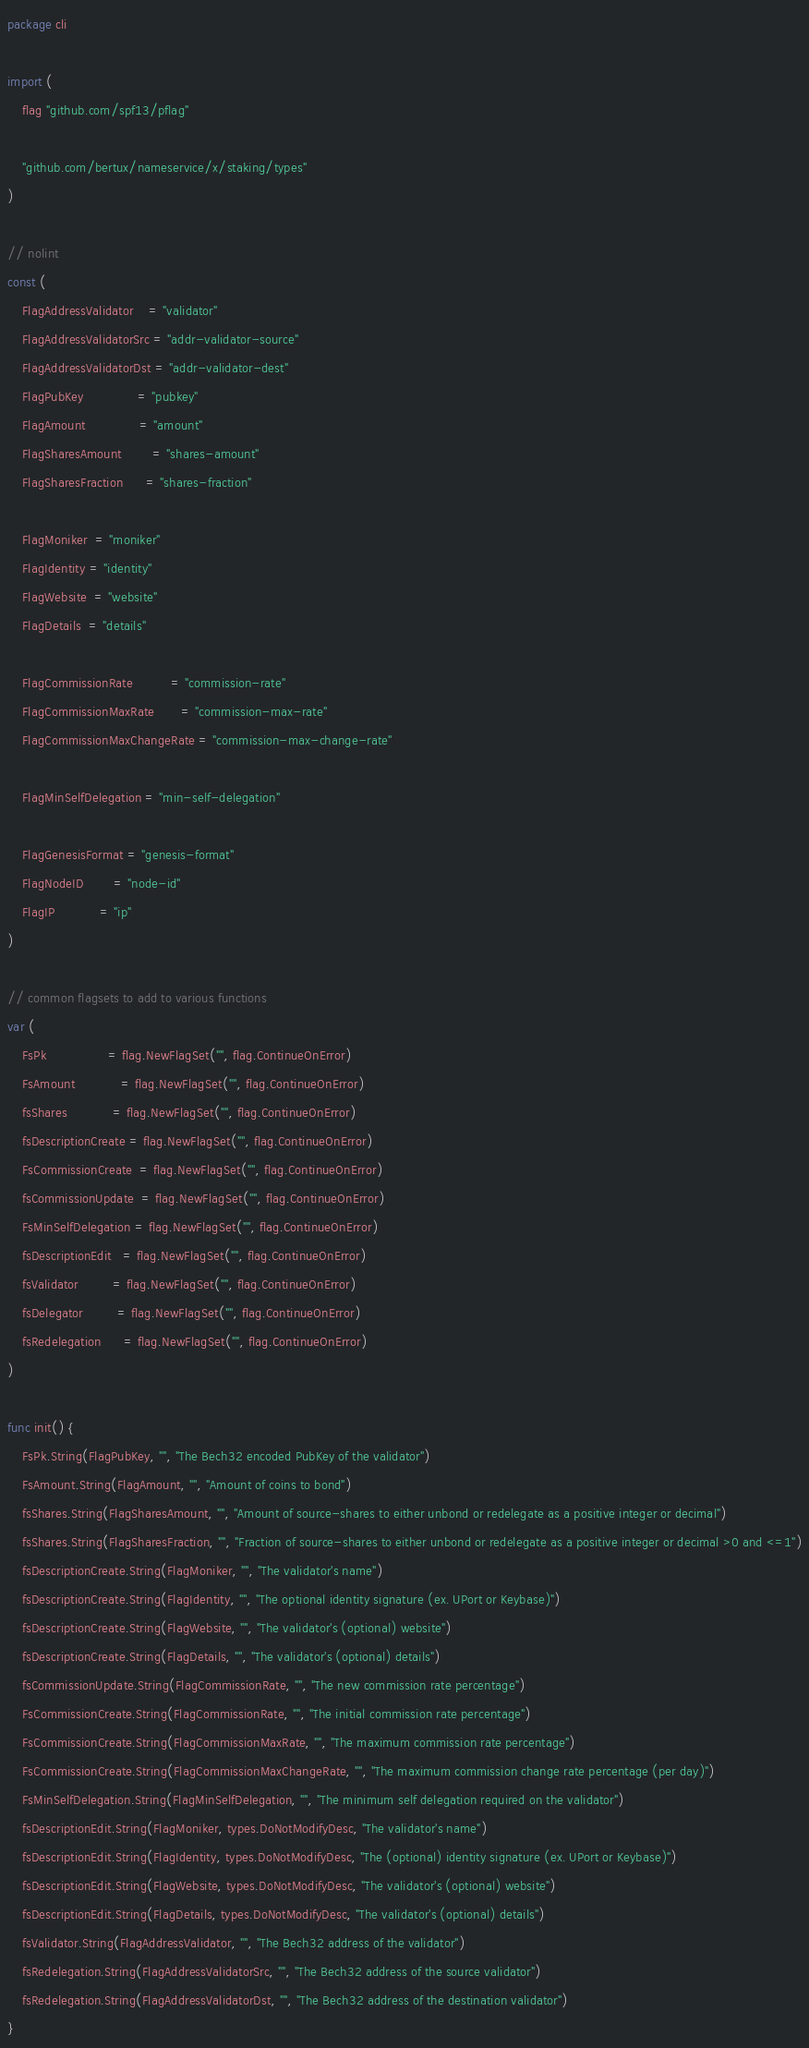Convert code to text. <code><loc_0><loc_0><loc_500><loc_500><_Go_>package cli

import (
	flag "github.com/spf13/pflag"

	"github.com/bertux/nameservice/x/staking/types"
)

// nolint
const (
	FlagAddressValidator    = "validator"
	FlagAddressValidatorSrc = "addr-validator-source"
	FlagAddressValidatorDst = "addr-validator-dest"
	FlagPubKey              = "pubkey"
	FlagAmount              = "amount"
	FlagSharesAmount        = "shares-amount"
	FlagSharesFraction      = "shares-fraction"

	FlagMoniker  = "moniker"
	FlagIdentity = "identity"
	FlagWebsite  = "website"
	FlagDetails  = "details"

	FlagCommissionRate          = "commission-rate"
	FlagCommissionMaxRate       = "commission-max-rate"
	FlagCommissionMaxChangeRate = "commission-max-change-rate"

	FlagMinSelfDelegation = "min-self-delegation"

	FlagGenesisFormat = "genesis-format"
	FlagNodeID        = "node-id"
	FlagIP            = "ip"
)

// common flagsets to add to various functions
var (
	FsPk                = flag.NewFlagSet("", flag.ContinueOnError)
	FsAmount            = flag.NewFlagSet("", flag.ContinueOnError)
	fsShares            = flag.NewFlagSet("", flag.ContinueOnError)
	fsDescriptionCreate = flag.NewFlagSet("", flag.ContinueOnError)
	FsCommissionCreate  = flag.NewFlagSet("", flag.ContinueOnError)
	fsCommissionUpdate  = flag.NewFlagSet("", flag.ContinueOnError)
	FsMinSelfDelegation = flag.NewFlagSet("", flag.ContinueOnError)
	fsDescriptionEdit   = flag.NewFlagSet("", flag.ContinueOnError)
	fsValidator         = flag.NewFlagSet("", flag.ContinueOnError)
	fsDelegator         = flag.NewFlagSet("", flag.ContinueOnError)
	fsRedelegation      = flag.NewFlagSet("", flag.ContinueOnError)
)

func init() {
	FsPk.String(FlagPubKey, "", "The Bech32 encoded PubKey of the validator")
	FsAmount.String(FlagAmount, "", "Amount of coins to bond")
	fsShares.String(FlagSharesAmount, "", "Amount of source-shares to either unbond or redelegate as a positive integer or decimal")
	fsShares.String(FlagSharesFraction, "", "Fraction of source-shares to either unbond or redelegate as a positive integer or decimal >0 and <=1")
	fsDescriptionCreate.String(FlagMoniker, "", "The validator's name")
	fsDescriptionCreate.String(FlagIdentity, "", "The optional identity signature (ex. UPort or Keybase)")
	fsDescriptionCreate.String(FlagWebsite, "", "The validator's (optional) website")
	fsDescriptionCreate.String(FlagDetails, "", "The validator's (optional) details")
	fsCommissionUpdate.String(FlagCommissionRate, "", "The new commission rate percentage")
	FsCommissionCreate.String(FlagCommissionRate, "", "The initial commission rate percentage")
	FsCommissionCreate.String(FlagCommissionMaxRate, "", "The maximum commission rate percentage")
	FsCommissionCreate.String(FlagCommissionMaxChangeRate, "", "The maximum commission change rate percentage (per day)")
	FsMinSelfDelegation.String(FlagMinSelfDelegation, "", "The minimum self delegation required on the validator")
	fsDescriptionEdit.String(FlagMoniker, types.DoNotModifyDesc, "The validator's name")
	fsDescriptionEdit.String(FlagIdentity, types.DoNotModifyDesc, "The (optional) identity signature (ex. UPort or Keybase)")
	fsDescriptionEdit.String(FlagWebsite, types.DoNotModifyDesc, "The validator's (optional) website")
	fsDescriptionEdit.String(FlagDetails, types.DoNotModifyDesc, "The validator's (optional) details")
	fsValidator.String(FlagAddressValidator, "", "The Bech32 address of the validator")
	fsRedelegation.String(FlagAddressValidatorSrc, "", "The Bech32 address of the source validator")
	fsRedelegation.String(FlagAddressValidatorDst, "", "The Bech32 address of the destination validator")
}
</code> 